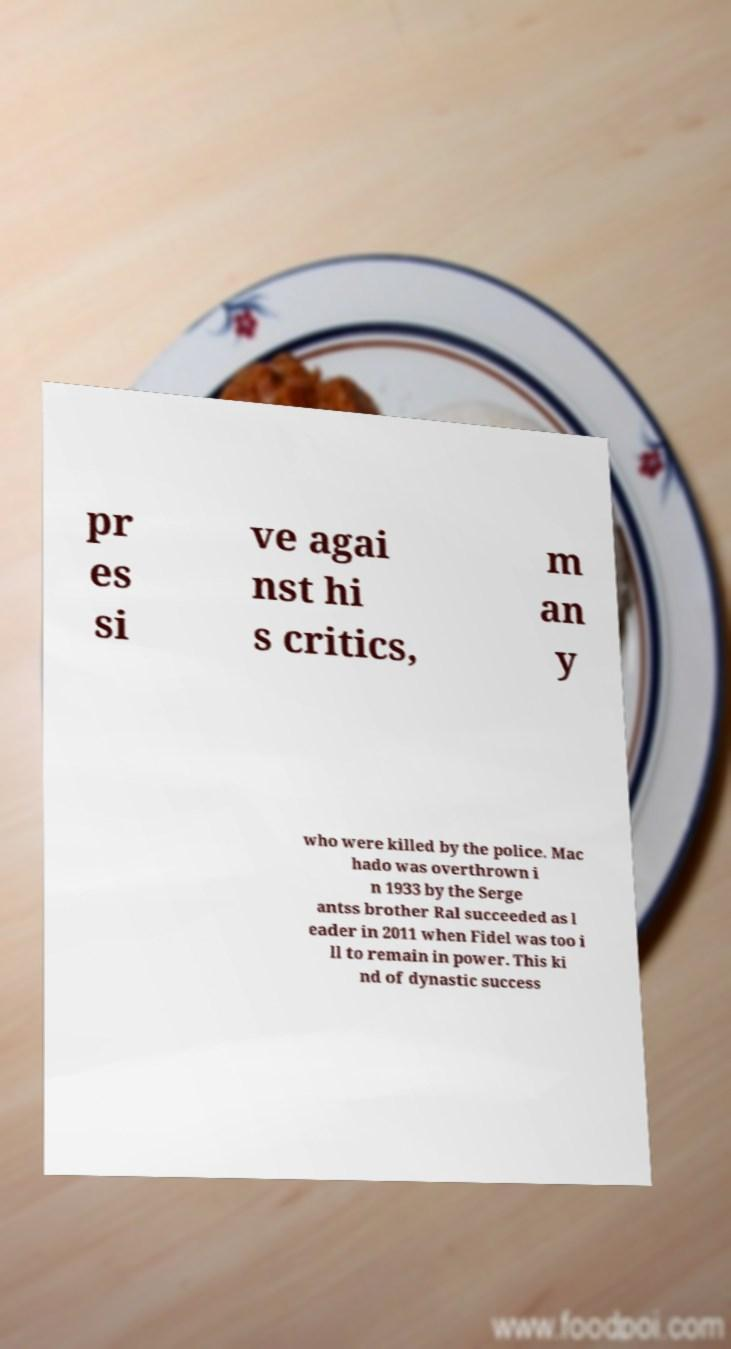Could you assist in decoding the text presented in this image and type it out clearly? pr es si ve agai nst hi s critics, m an y who were killed by the police. Mac hado was overthrown i n 1933 by the Serge antss brother Ral succeeded as l eader in 2011 when Fidel was too i ll to remain in power. This ki nd of dynastic success 